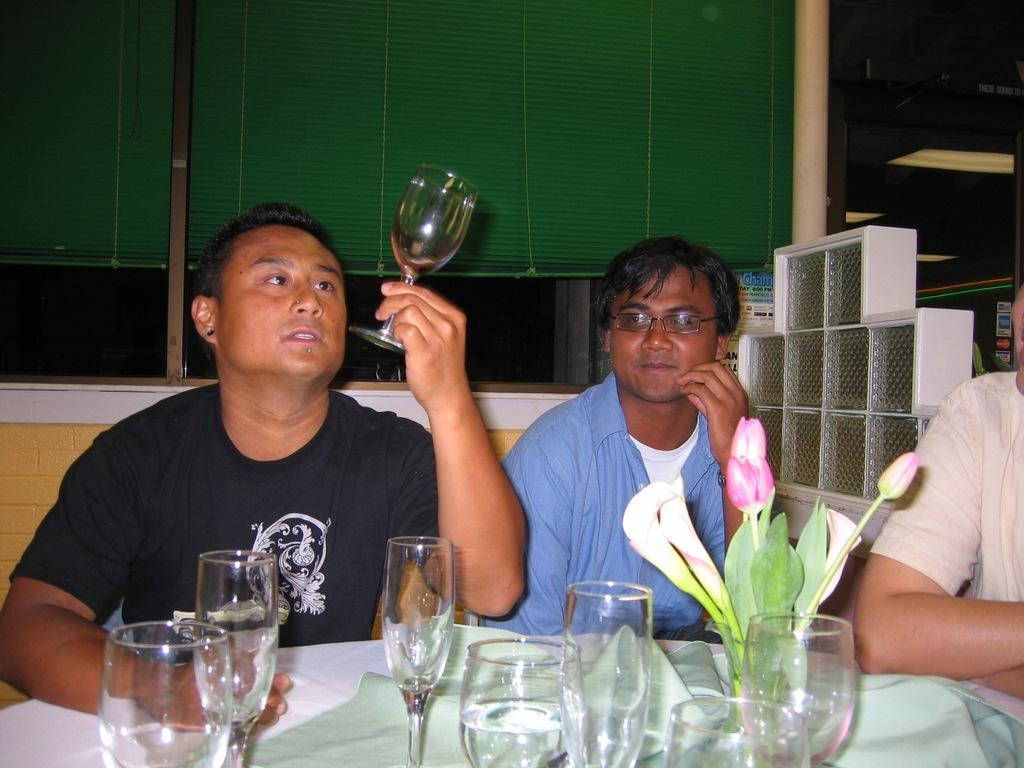How many people are in the image? There are two persons in the image. What are the persons doing in the image? The persons are sitting on chairs. What is present on the table in the image? There are glasses and a flower vase on the table. How is one person interacting with the glasses on the table? One person is holding a glass with their hand. What type of stick can be seen leaning against the window in the image? There is no stick or window present in the image. Can you describe the cellar in the image? There is no cellar present in the image. 